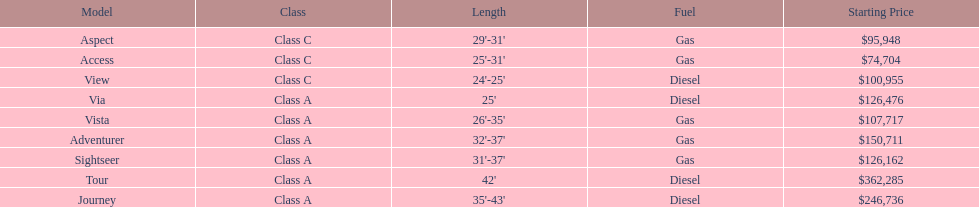Which model is at the top of the list with the highest starting price? Tour. 